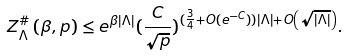<formula> <loc_0><loc_0><loc_500><loc_500>Z _ { \Lambda } ^ { \# } \left ( \beta , p \right ) \leq e ^ { \beta \left | \Lambda \right | } ( { \frac { C } { \sqrt { p } } } ) ^ { ( \frac { 3 } { 4 } + O ( e ^ { - C } ) ) \left | \Lambda \right | + O \left ( \sqrt { \left | \Lambda \right | } \right ) } .</formula> 